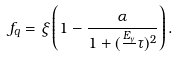Convert formula to latex. <formula><loc_0><loc_0><loc_500><loc_500>f _ { q } = \xi \left ( 1 - \frac { \alpha } { 1 + ( \frac { E _ { \gamma } } { } \tau ) ^ { 2 } } \right ) .</formula> 